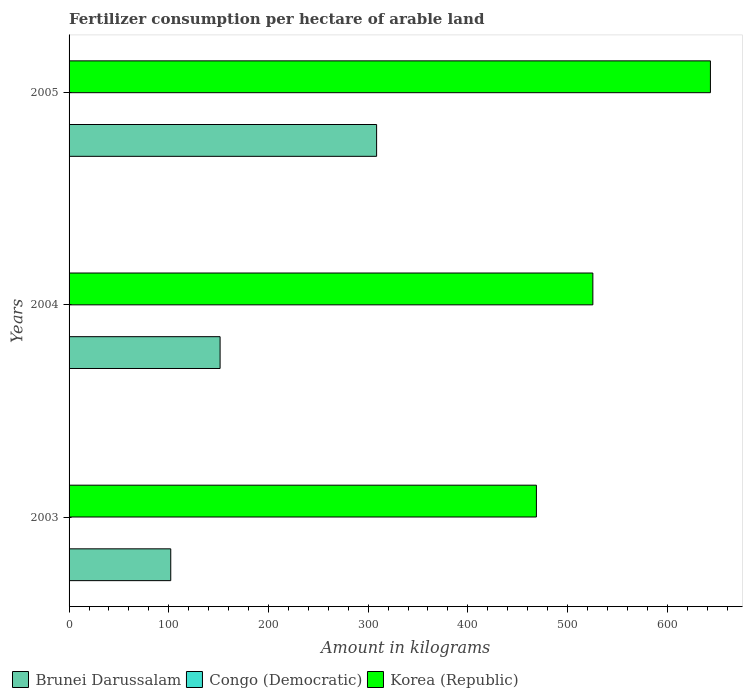What is the label of the 1st group of bars from the top?
Provide a short and direct response. 2005. What is the amount of fertilizer consumption in Korea (Republic) in 2004?
Offer a terse response. 525.42. Across all years, what is the maximum amount of fertilizer consumption in Brunei Darussalam?
Offer a very short reply. 308.5. Across all years, what is the minimum amount of fertilizer consumption in Congo (Democratic)?
Give a very brief answer. 0.07. In which year was the amount of fertilizer consumption in Congo (Democratic) maximum?
Make the answer very short. 2003. What is the total amount of fertilizer consumption in Brunei Darussalam in the graph?
Keep it short and to the point. 562. What is the difference between the amount of fertilizer consumption in Brunei Darussalam in 2003 and that in 2004?
Your response must be concise. -49.5. What is the difference between the amount of fertilizer consumption in Korea (Republic) in 2005 and the amount of fertilizer consumption in Brunei Darussalam in 2003?
Keep it short and to the point. 541.36. What is the average amount of fertilizer consumption in Korea (Republic) per year?
Keep it short and to the point. 545.86. In the year 2004, what is the difference between the amount of fertilizer consumption in Korea (Republic) and amount of fertilizer consumption in Congo (Democratic)?
Offer a terse response. 525.21. In how many years, is the amount of fertilizer consumption in Brunei Darussalam greater than 400 kg?
Your answer should be compact. 0. What is the ratio of the amount of fertilizer consumption in Brunei Darussalam in 2003 to that in 2004?
Your answer should be very brief. 0.67. Is the difference between the amount of fertilizer consumption in Korea (Republic) in 2003 and 2004 greater than the difference between the amount of fertilizer consumption in Congo (Democratic) in 2003 and 2004?
Make the answer very short. No. What is the difference between the highest and the second highest amount of fertilizer consumption in Congo (Democratic)?
Ensure brevity in your answer.  0.07. What is the difference between the highest and the lowest amount of fertilizer consumption in Brunei Darussalam?
Your answer should be very brief. 206.5. What does the 3rd bar from the top in 2003 represents?
Offer a very short reply. Brunei Darussalam. What does the 3rd bar from the bottom in 2003 represents?
Offer a terse response. Korea (Republic). Is it the case that in every year, the sum of the amount of fertilizer consumption in Congo (Democratic) and amount of fertilizer consumption in Korea (Republic) is greater than the amount of fertilizer consumption in Brunei Darussalam?
Your answer should be very brief. Yes. How many years are there in the graph?
Offer a very short reply. 3. Does the graph contain grids?
Make the answer very short. No. How are the legend labels stacked?
Offer a terse response. Horizontal. What is the title of the graph?
Your answer should be compact. Fertilizer consumption per hectare of arable land. What is the label or title of the X-axis?
Make the answer very short. Amount in kilograms. What is the Amount in kilograms of Brunei Darussalam in 2003?
Your response must be concise. 102. What is the Amount in kilograms of Congo (Democratic) in 2003?
Your response must be concise. 0.28. What is the Amount in kilograms in Korea (Republic) in 2003?
Provide a short and direct response. 468.79. What is the Amount in kilograms in Brunei Darussalam in 2004?
Keep it short and to the point. 151.5. What is the Amount in kilograms in Congo (Democratic) in 2004?
Your response must be concise. 0.21. What is the Amount in kilograms in Korea (Republic) in 2004?
Offer a terse response. 525.42. What is the Amount in kilograms of Brunei Darussalam in 2005?
Your response must be concise. 308.5. What is the Amount in kilograms of Congo (Democratic) in 2005?
Provide a succinct answer. 0.07. What is the Amount in kilograms of Korea (Republic) in 2005?
Provide a succinct answer. 643.36. Across all years, what is the maximum Amount in kilograms in Brunei Darussalam?
Keep it short and to the point. 308.5. Across all years, what is the maximum Amount in kilograms in Congo (Democratic)?
Make the answer very short. 0.28. Across all years, what is the maximum Amount in kilograms in Korea (Republic)?
Give a very brief answer. 643.36. Across all years, what is the minimum Amount in kilograms in Brunei Darussalam?
Make the answer very short. 102. Across all years, what is the minimum Amount in kilograms of Congo (Democratic)?
Provide a short and direct response. 0.07. Across all years, what is the minimum Amount in kilograms in Korea (Republic)?
Provide a succinct answer. 468.79. What is the total Amount in kilograms of Brunei Darussalam in the graph?
Ensure brevity in your answer.  562. What is the total Amount in kilograms in Congo (Democratic) in the graph?
Offer a terse response. 0.55. What is the total Amount in kilograms in Korea (Republic) in the graph?
Your answer should be compact. 1637.57. What is the difference between the Amount in kilograms of Brunei Darussalam in 2003 and that in 2004?
Offer a very short reply. -49.5. What is the difference between the Amount in kilograms in Congo (Democratic) in 2003 and that in 2004?
Give a very brief answer. 0.07. What is the difference between the Amount in kilograms of Korea (Republic) in 2003 and that in 2004?
Offer a very short reply. -56.63. What is the difference between the Amount in kilograms in Brunei Darussalam in 2003 and that in 2005?
Your answer should be very brief. -206.5. What is the difference between the Amount in kilograms in Congo (Democratic) in 2003 and that in 2005?
Your answer should be very brief. 0.21. What is the difference between the Amount in kilograms of Korea (Republic) in 2003 and that in 2005?
Provide a short and direct response. -174.57. What is the difference between the Amount in kilograms of Brunei Darussalam in 2004 and that in 2005?
Your response must be concise. -157. What is the difference between the Amount in kilograms in Congo (Democratic) in 2004 and that in 2005?
Your response must be concise. 0.14. What is the difference between the Amount in kilograms in Korea (Republic) in 2004 and that in 2005?
Provide a succinct answer. -117.94. What is the difference between the Amount in kilograms of Brunei Darussalam in 2003 and the Amount in kilograms of Congo (Democratic) in 2004?
Ensure brevity in your answer.  101.79. What is the difference between the Amount in kilograms in Brunei Darussalam in 2003 and the Amount in kilograms in Korea (Republic) in 2004?
Provide a succinct answer. -423.42. What is the difference between the Amount in kilograms in Congo (Democratic) in 2003 and the Amount in kilograms in Korea (Republic) in 2004?
Offer a very short reply. -525.15. What is the difference between the Amount in kilograms in Brunei Darussalam in 2003 and the Amount in kilograms in Congo (Democratic) in 2005?
Provide a short and direct response. 101.93. What is the difference between the Amount in kilograms of Brunei Darussalam in 2003 and the Amount in kilograms of Korea (Republic) in 2005?
Provide a short and direct response. -541.36. What is the difference between the Amount in kilograms in Congo (Democratic) in 2003 and the Amount in kilograms in Korea (Republic) in 2005?
Your answer should be very brief. -643.08. What is the difference between the Amount in kilograms in Brunei Darussalam in 2004 and the Amount in kilograms in Congo (Democratic) in 2005?
Your response must be concise. 151.43. What is the difference between the Amount in kilograms in Brunei Darussalam in 2004 and the Amount in kilograms in Korea (Republic) in 2005?
Make the answer very short. -491.86. What is the difference between the Amount in kilograms of Congo (Democratic) in 2004 and the Amount in kilograms of Korea (Republic) in 2005?
Make the answer very short. -643.15. What is the average Amount in kilograms of Brunei Darussalam per year?
Provide a short and direct response. 187.33. What is the average Amount in kilograms in Congo (Democratic) per year?
Your answer should be compact. 0.18. What is the average Amount in kilograms in Korea (Republic) per year?
Provide a succinct answer. 545.86. In the year 2003, what is the difference between the Amount in kilograms in Brunei Darussalam and Amount in kilograms in Congo (Democratic)?
Your answer should be compact. 101.72. In the year 2003, what is the difference between the Amount in kilograms in Brunei Darussalam and Amount in kilograms in Korea (Republic)?
Your answer should be very brief. -366.79. In the year 2003, what is the difference between the Amount in kilograms in Congo (Democratic) and Amount in kilograms in Korea (Republic)?
Offer a very short reply. -468.51. In the year 2004, what is the difference between the Amount in kilograms of Brunei Darussalam and Amount in kilograms of Congo (Democratic)?
Your response must be concise. 151.29. In the year 2004, what is the difference between the Amount in kilograms of Brunei Darussalam and Amount in kilograms of Korea (Republic)?
Keep it short and to the point. -373.92. In the year 2004, what is the difference between the Amount in kilograms in Congo (Democratic) and Amount in kilograms in Korea (Republic)?
Offer a very short reply. -525.21. In the year 2005, what is the difference between the Amount in kilograms in Brunei Darussalam and Amount in kilograms in Congo (Democratic)?
Your response must be concise. 308.43. In the year 2005, what is the difference between the Amount in kilograms in Brunei Darussalam and Amount in kilograms in Korea (Republic)?
Your answer should be compact. -334.86. In the year 2005, what is the difference between the Amount in kilograms in Congo (Democratic) and Amount in kilograms in Korea (Republic)?
Give a very brief answer. -643.29. What is the ratio of the Amount in kilograms in Brunei Darussalam in 2003 to that in 2004?
Offer a very short reply. 0.67. What is the ratio of the Amount in kilograms of Congo (Democratic) in 2003 to that in 2004?
Your answer should be compact. 1.32. What is the ratio of the Amount in kilograms of Korea (Republic) in 2003 to that in 2004?
Your answer should be very brief. 0.89. What is the ratio of the Amount in kilograms of Brunei Darussalam in 2003 to that in 2005?
Offer a very short reply. 0.33. What is the ratio of the Amount in kilograms in Congo (Democratic) in 2003 to that in 2005?
Give a very brief answer. 4.06. What is the ratio of the Amount in kilograms in Korea (Republic) in 2003 to that in 2005?
Provide a succinct answer. 0.73. What is the ratio of the Amount in kilograms in Brunei Darussalam in 2004 to that in 2005?
Provide a succinct answer. 0.49. What is the ratio of the Amount in kilograms in Congo (Democratic) in 2004 to that in 2005?
Keep it short and to the point. 3.07. What is the ratio of the Amount in kilograms of Korea (Republic) in 2004 to that in 2005?
Provide a succinct answer. 0.82. What is the difference between the highest and the second highest Amount in kilograms of Brunei Darussalam?
Ensure brevity in your answer.  157. What is the difference between the highest and the second highest Amount in kilograms in Congo (Democratic)?
Your answer should be very brief. 0.07. What is the difference between the highest and the second highest Amount in kilograms in Korea (Republic)?
Your response must be concise. 117.94. What is the difference between the highest and the lowest Amount in kilograms of Brunei Darussalam?
Provide a short and direct response. 206.5. What is the difference between the highest and the lowest Amount in kilograms of Congo (Democratic)?
Offer a very short reply. 0.21. What is the difference between the highest and the lowest Amount in kilograms of Korea (Republic)?
Make the answer very short. 174.57. 